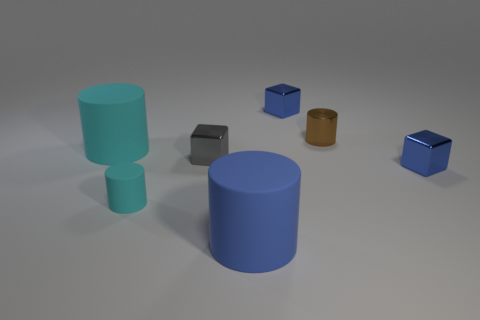Add 3 brown things. How many objects exist? 10 Subtract all small brown cylinders. How many cylinders are left? 3 Subtract 4 cylinders. How many cylinders are left? 0 Subtract all cylinders. How many objects are left? 3 Subtract all brown cubes. Subtract all green spheres. How many cubes are left? 3 Subtract all gray spheres. How many gray cubes are left? 1 Subtract all tiny metallic things. Subtract all blue things. How many objects are left? 0 Add 6 gray shiny cubes. How many gray shiny cubes are left? 7 Add 4 large matte cylinders. How many large matte cylinders exist? 6 Subtract all gray cubes. How many cubes are left? 2 